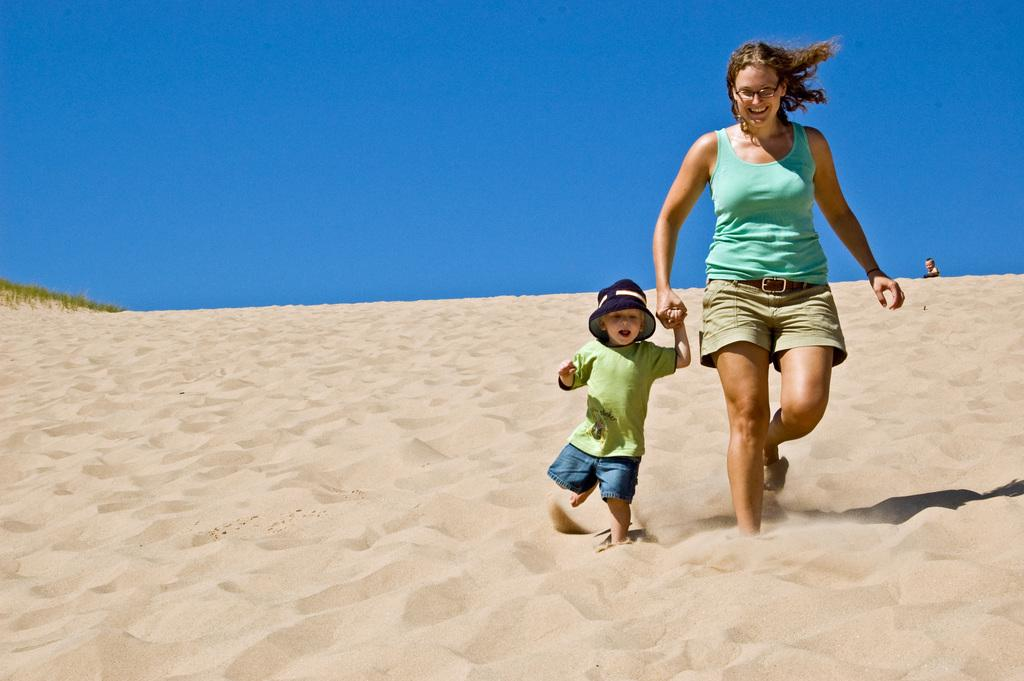Who is present in the image? There is a woman and a boy in the image. What are the woman and the boy doing in the image? Both the woman and the boy are walking in the desert. What is the ground made of in the image? The bottom of the image consists of sand. What is the boy wearing on his head? The boy is wearing a hat. What can be seen at the top of the image? There is a sky visible at the top of the image. What type of duck can be seen pulling a cart in the image? There is no duck or cart present in the image; it features a woman and a boy walking in the desert. What company is responsible for the desert in the image? The image does not indicate any specific company responsible for the desert; it is a natural landscape. 